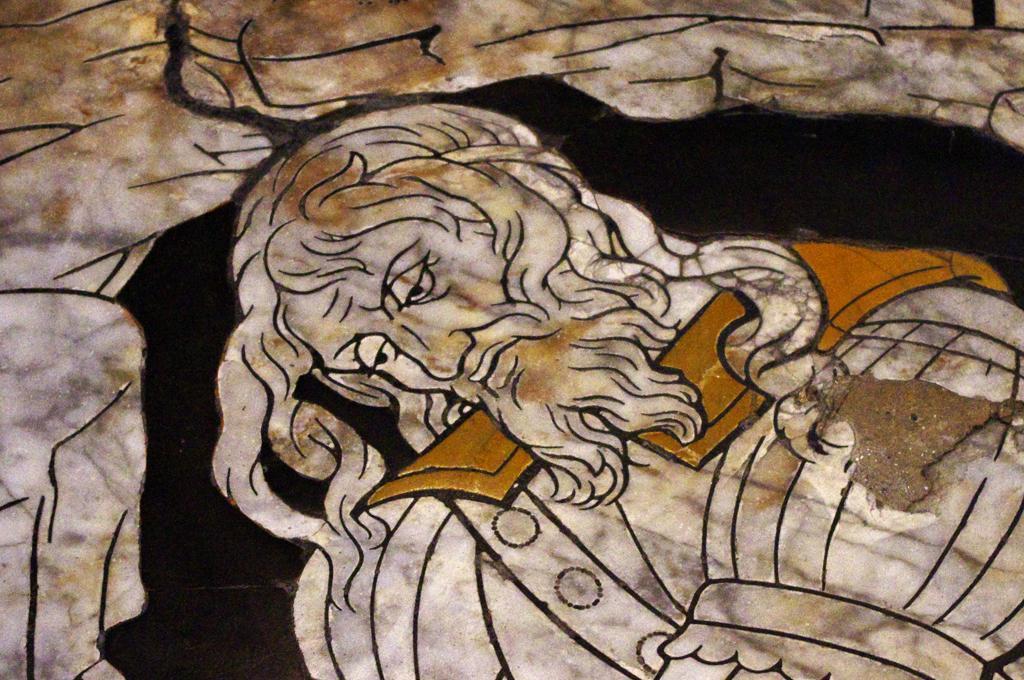In one or two sentences, can you explain what this image depicts? In this image I can see the painting of the person and the painting is in cream, brown, black and white color. 